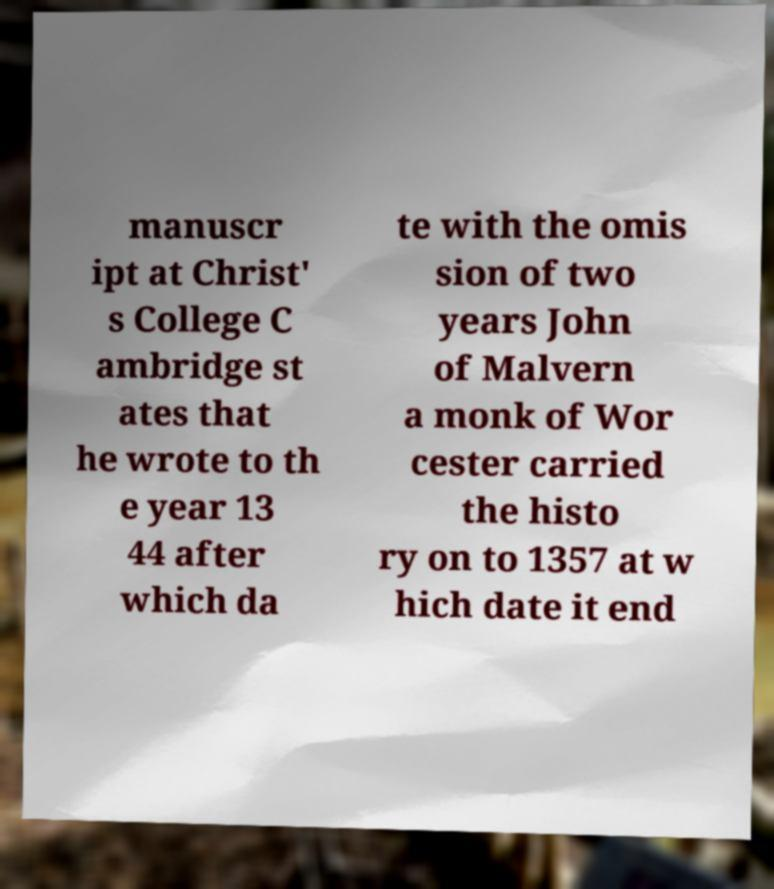Please identify and transcribe the text found in this image. manuscr ipt at Christ' s College C ambridge st ates that he wrote to th e year 13 44 after which da te with the omis sion of two years John of Malvern a monk of Wor cester carried the histo ry on to 1357 at w hich date it end 